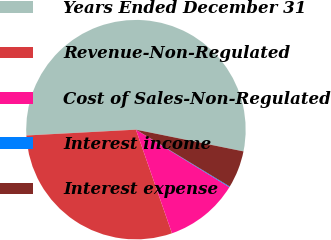<chart> <loc_0><loc_0><loc_500><loc_500><pie_chart><fcel>Years Ended December 31<fcel>Revenue-Non-Regulated<fcel>Cost of Sales-Non-Regulated<fcel>Interest income<fcel>Interest expense<nl><fcel>54.03%<fcel>29.48%<fcel>10.89%<fcel>0.11%<fcel>5.5%<nl></chart> 